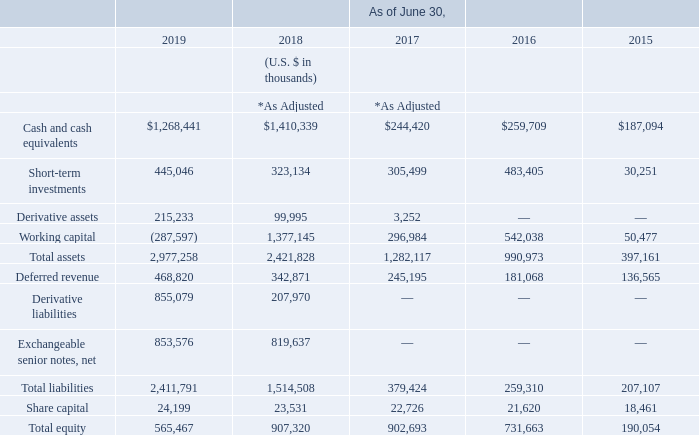Consolidated Statements of Financial Position Data:
* Adjusted IFRS balances to reflect the impact of the full retrospective adoption of IFRS 15. See Note 2 of the notes to our consolidated financial statements for further details.
What do the adjusted IFRS balances reflect? The impact of the full retrospective adoption of ifrs 15. What are the share capital for the years as of June 30, 2015 to 2019 in chronological order?
Answer scale should be: thousand. 18,461, 21,620, 22,726, 23,531, 24,199. What are the short-term investments for the years as of June 30, 2015 to 2019 in chronological order?
Answer scale should be: thousand. 30,251, 483,405, 305,499, 323,134, 445,046. What is the difference in the value of short-term investments between fiscal years 2018 and 2019?
Answer scale should be: thousand. 445,046-323,134
Answer: 121912. What is the average  Total equity  for fiscal years 2015 to 2019?
Answer scale should be: thousand. ( 565,467 + 907,320+ 902,693 + 731,663 + 190,054  )/5
Answer: 659439.4. What is the average  Cash and cash equivalents for 2015-2019?
Answer scale should be: thousand. (1,268,441+1,410,339+244,420+259,709+187,094)/5
Answer: 674000.6. 